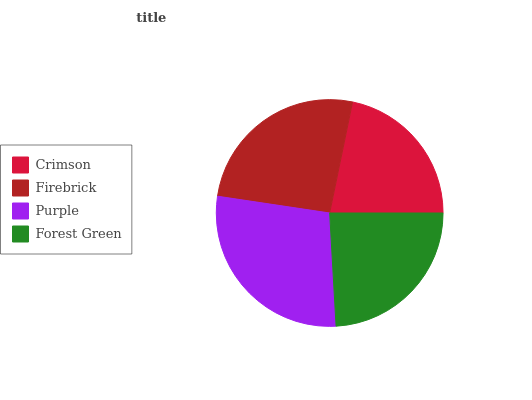Is Crimson the minimum?
Answer yes or no. Yes. Is Purple the maximum?
Answer yes or no. Yes. Is Firebrick the minimum?
Answer yes or no. No. Is Firebrick the maximum?
Answer yes or no. No. Is Firebrick greater than Crimson?
Answer yes or no. Yes. Is Crimson less than Firebrick?
Answer yes or no. Yes. Is Crimson greater than Firebrick?
Answer yes or no. No. Is Firebrick less than Crimson?
Answer yes or no. No. Is Firebrick the high median?
Answer yes or no. Yes. Is Forest Green the low median?
Answer yes or no. Yes. Is Forest Green the high median?
Answer yes or no. No. Is Firebrick the low median?
Answer yes or no. No. 